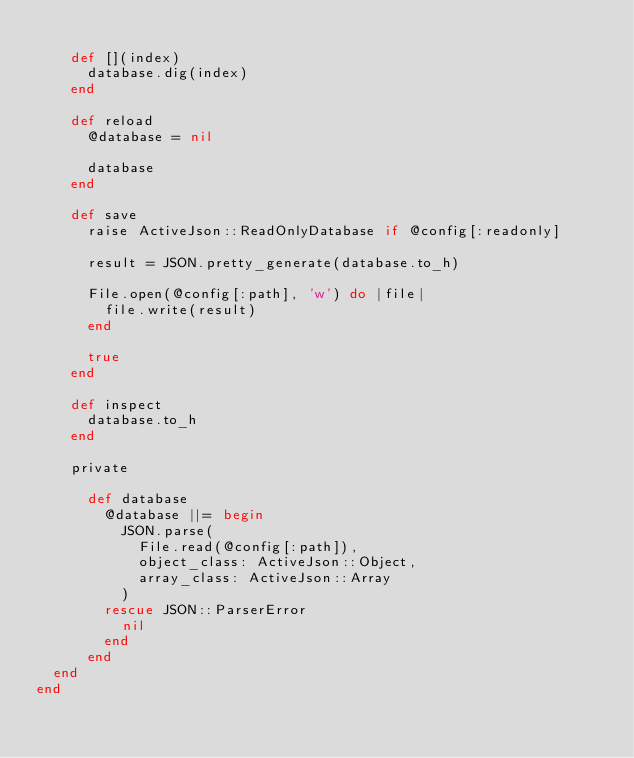<code> <loc_0><loc_0><loc_500><loc_500><_Ruby_>
    def [](index)
      database.dig(index)
    end

    def reload
      @database = nil

      database
    end

    def save
      raise ActiveJson::ReadOnlyDatabase if @config[:readonly]

      result = JSON.pretty_generate(database.to_h)

      File.open(@config[:path], 'w') do |file|
        file.write(result)
      end

      true
    end

    def inspect
      database.to_h
    end

    private

      def database
        @database ||= begin
          JSON.parse(
            File.read(@config[:path]),
            object_class: ActiveJson::Object,
            array_class: ActiveJson::Array
          )
        rescue JSON::ParserError
          nil
        end
      end
  end
end
</code> 